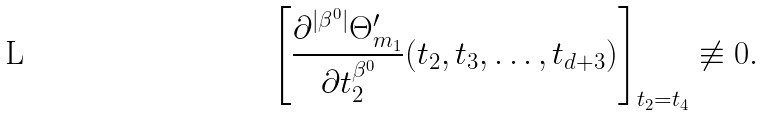Convert formula to latex. <formula><loc_0><loc_0><loc_500><loc_500>\left [ \frac { \partial ^ { | \beta ^ { 0 } | } \Theta ^ { \prime } _ { m _ { 1 } } } { \partial t _ { 2 } ^ { \beta ^ { 0 } } } ( t _ { 2 } , t _ { 3 } , \dots , t _ { d + 3 } ) \right ] _ { t _ { 2 } = t _ { 4 } } \not \equiv 0 .</formula> 